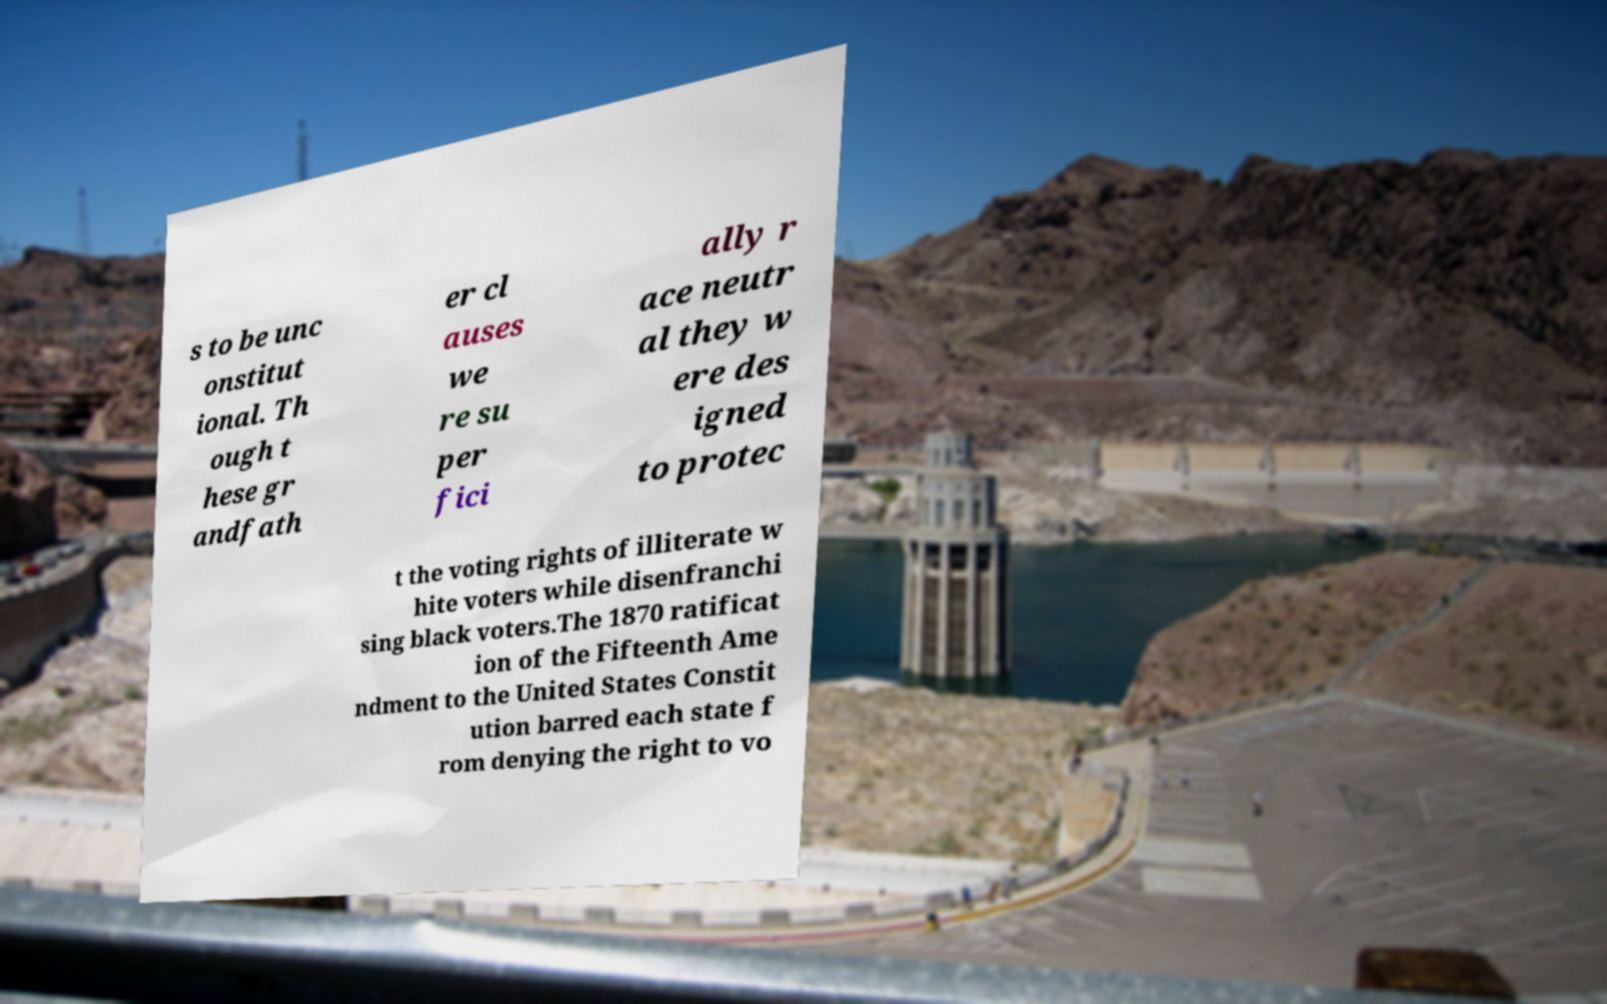Please read and relay the text visible in this image. What does it say? s to be unc onstitut ional. Th ough t hese gr andfath er cl auses we re su per fici ally r ace neutr al they w ere des igned to protec t the voting rights of illiterate w hite voters while disenfranchi sing black voters.The 1870 ratificat ion of the Fifteenth Ame ndment to the United States Constit ution barred each state f rom denying the right to vo 